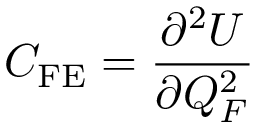Convert formula to latex. <formula><loc_0><loc_0><loc_500><loc_500>C _ { F E } = \frac { \partial ^ { 2 } U } { \partial Q _ { F } ^ { 2 } }</formula> 